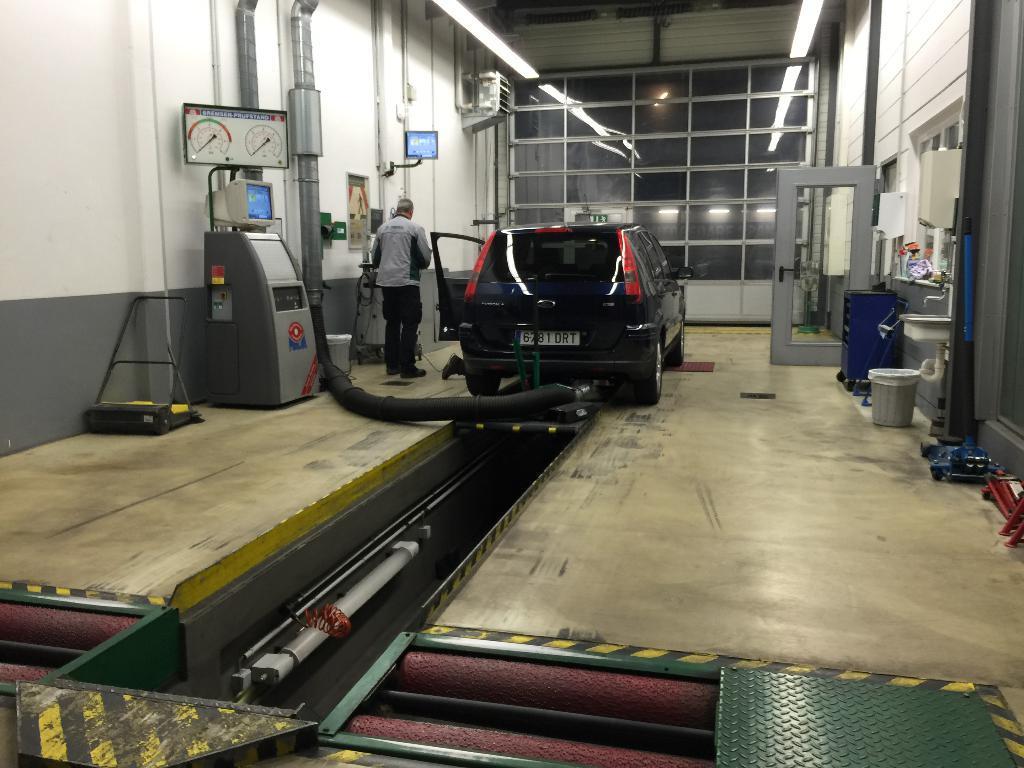Could you give a brief overview of what you see in this image? In this image I can see the interior of the building in which I can see the cream colored floor, the car which is black in color, few pipes, few electronic devices, a person standing, the door, the glass wall and few other objects. I can see the white colored wall and few lights. 